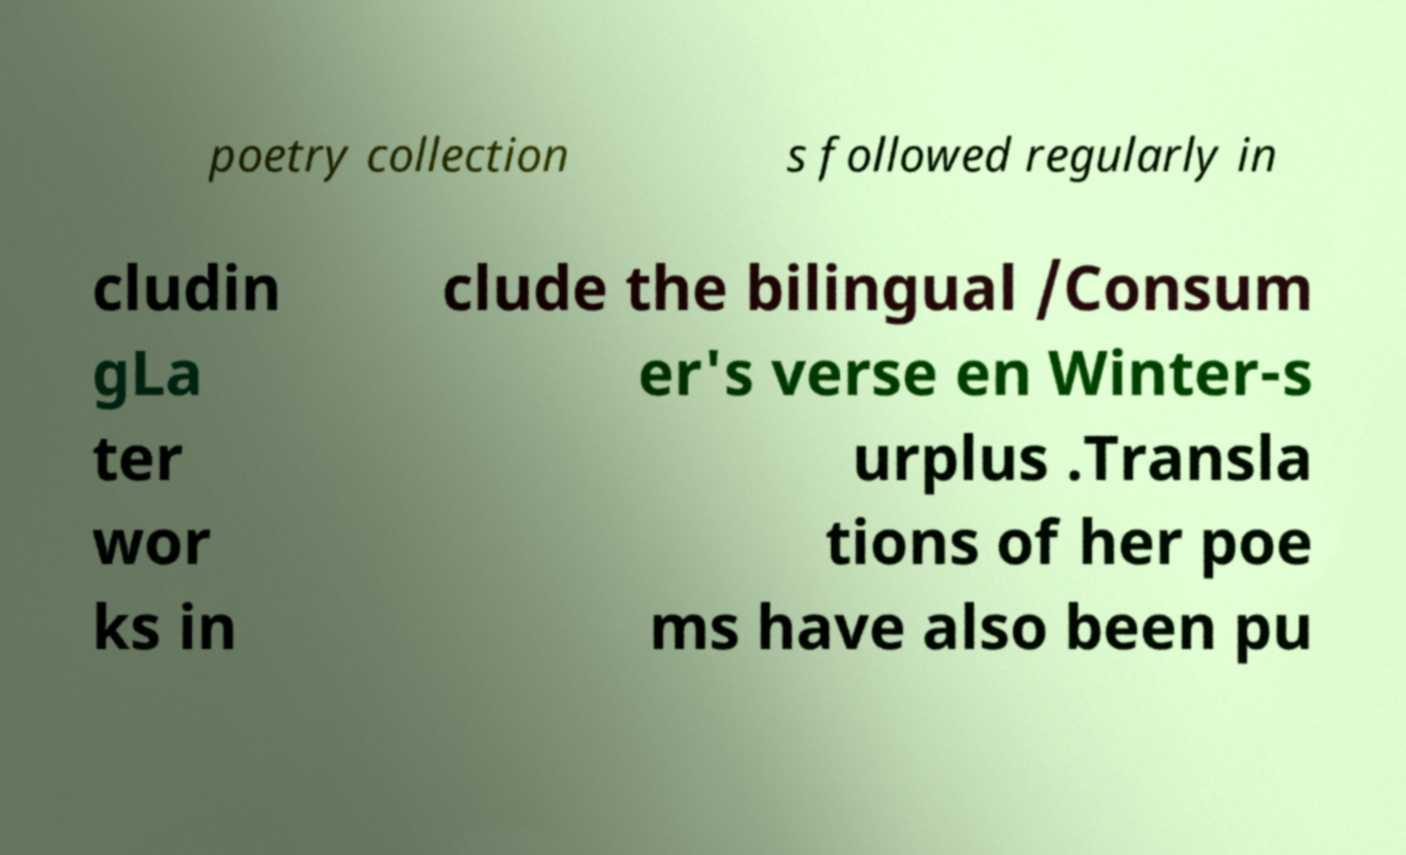Can you read and provide the text displayed in the image?This photo seems to have some interesting text. Can you extract and type it out for me? poetry collection s followed regularly in cludin gLa ter wor ks in clude the bilingual /Consum er's verse en Winter-s urplus .Transla tions of her poe ms have also been pu 